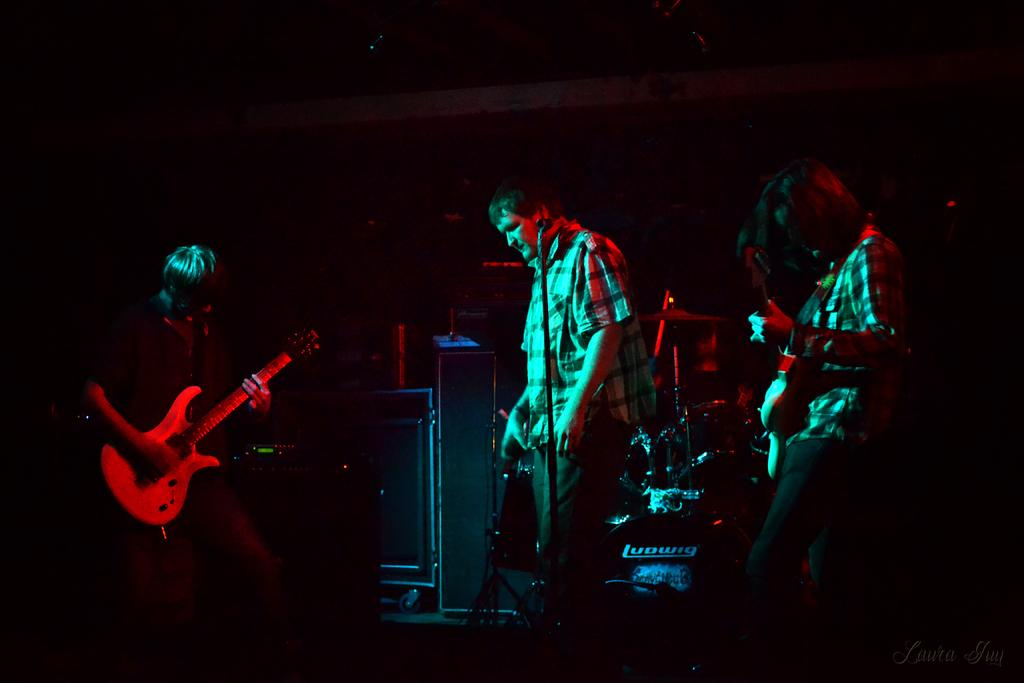How many people are in the image? There is a group of persons in the image. What are the persons doing in the image? The persons are standing and playing musical instruments. What can be seen in the background of the image? There are sound boxes in the background of the image. What type of seed is being exchanged between the persons in the image? There is no seed or exchange of any kind depicted in the image; the persons are playing musical instruments. Can you see any fangs on the persons in the image? There are no fangs visible on the persons in the image; they are playing musical instruments. 